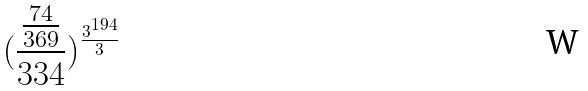Convert formula to latex. <formula><loc_0><loc_0><loc_500><loc_500>( \frac { \frac { 7 4 } { 3 6 9 } } { 3 3 4 } ) ^ { \frac { 3 ^ { 1 9 4 } } { 3 } }</formula> 